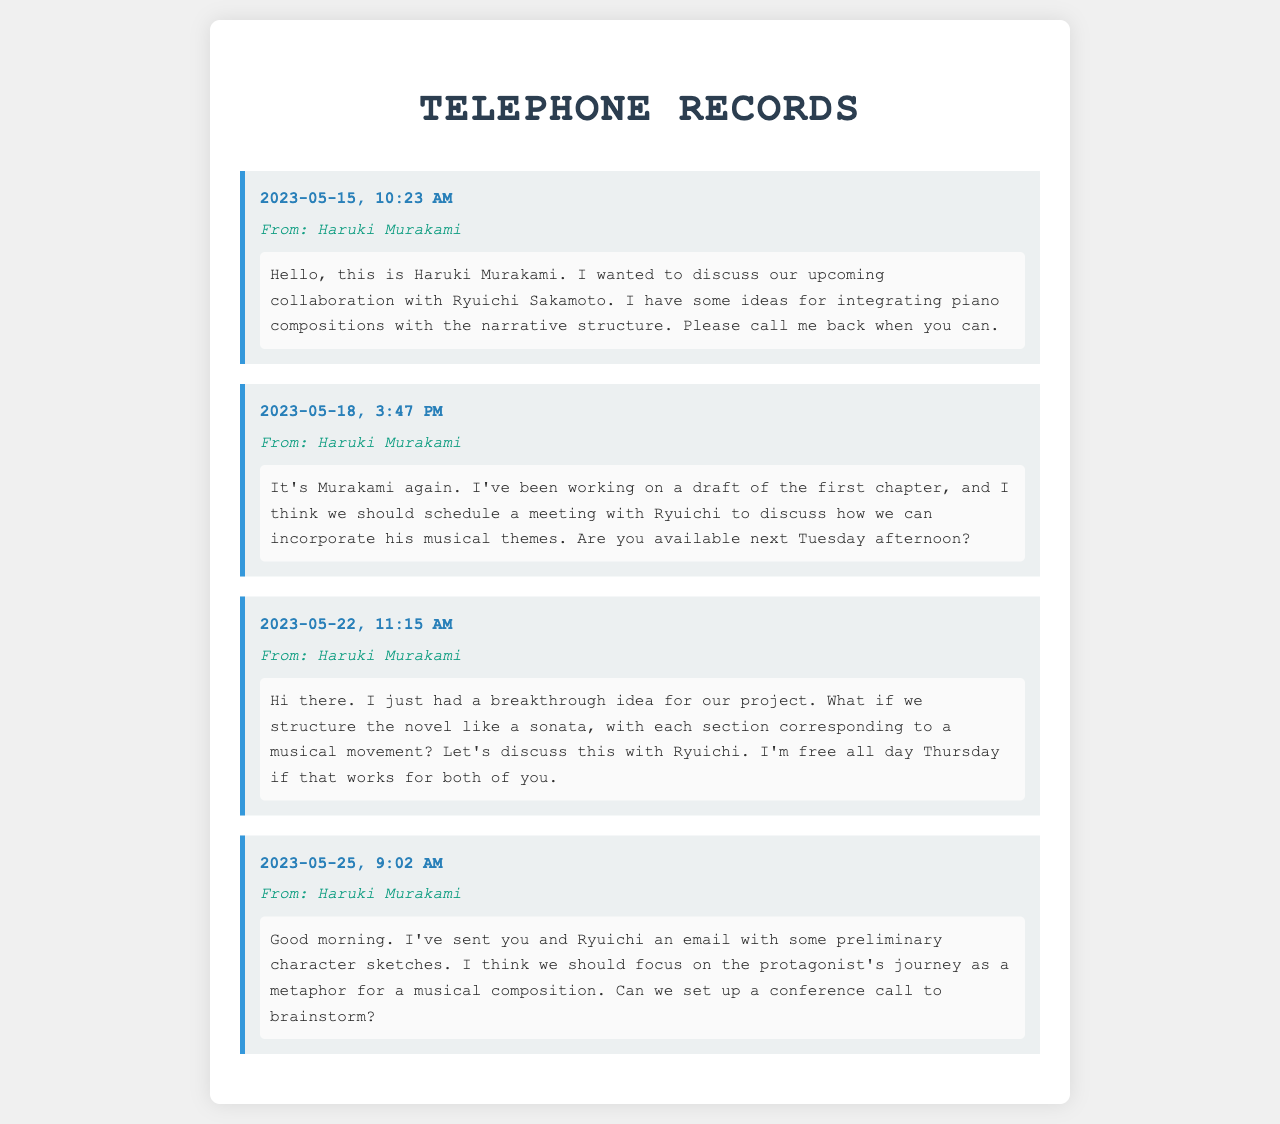what date did Murakami leave his first message? The first message was left on May 15, 2023, which is detailed in the document.
Answer: May 15, 2023 who is involved in the collaboration? The collaboration involves Haruki Murakami and Ryuichi Sakamoto, as mentioned in the messages.
Answer: Haruki Murakami and Ryuichi Sakamoto what time was the second message left? The time of the second message is specified as 3:47 PM on May 18, 2023.
Answer: 3:47 PM how does Murakami want to structure the novel? He suggests structuring it like a sonata, as indicated in his message on May 22.
Answer: like a sonata when did Murakami send the email with character sketches? The email was sent on May 25, 2023, which is noted in his message.
Answer: May 25, 2023 what is the main focus of the protagonist according to Murakami? Murakami emphasizes the protagonist's journey as a metaphor for a musical composition.
Answer: a metaphor for a musical composition what day of the week does Murakami suggest for a meeting? He proposes a meeting for Thursday in his message about the novel structure.
Answer: Thursday how many voicemail messages are recorded in total? There are four voicemail messages included in the document.
Answer: four 